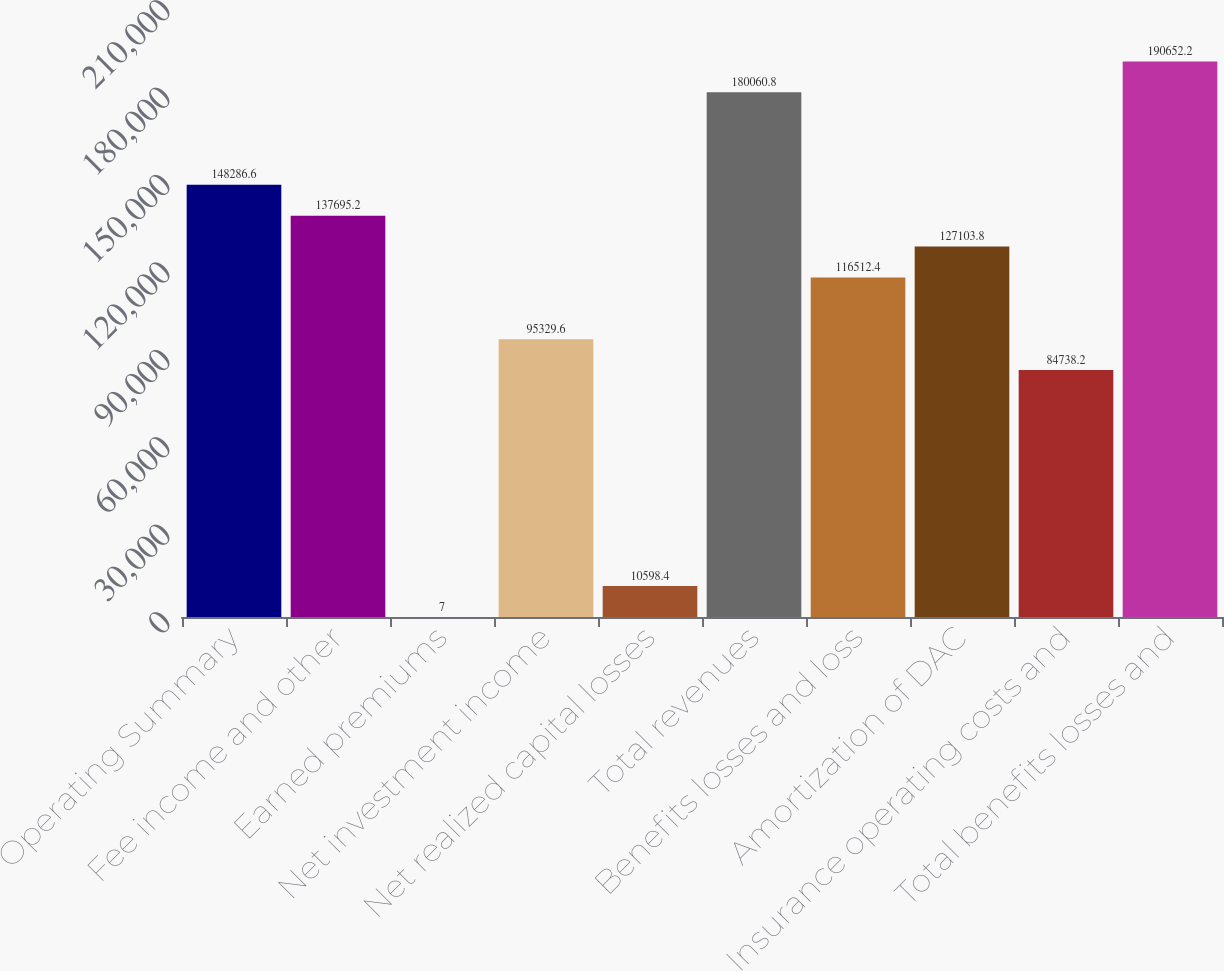<chart> <loc_0><loc_0><loc_500><loc_500><bar_chart><fcel>Operating Summary<fcel>Fee income and other<fcel>Earned premiums<fcel>Net investment income<fcel>Net realized capital losses<fcel>Total revenues<fcel>Benefits losses and loss<fcel>Amortization of DAC<fcel>Insurance operating costs and<fcel>Total benefits losses and<nl><fcel>148287<fcel>137695<fcel>7<fcel>95329.6<fcel>10598.4<fcel>180061<fcel>116512<fcel>127104<fcel>84738.2<fcel>190652<nl></chart> 